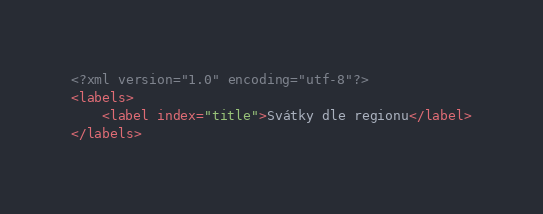Convert code to text. <code><loc_0><loc_0><loc_500><loc_500><_XML_><?xml version="1.0" encoding="utf-8"?>
<labels>
	<label index="title">Svátky dle regionu</label>
</labels>
</code> 